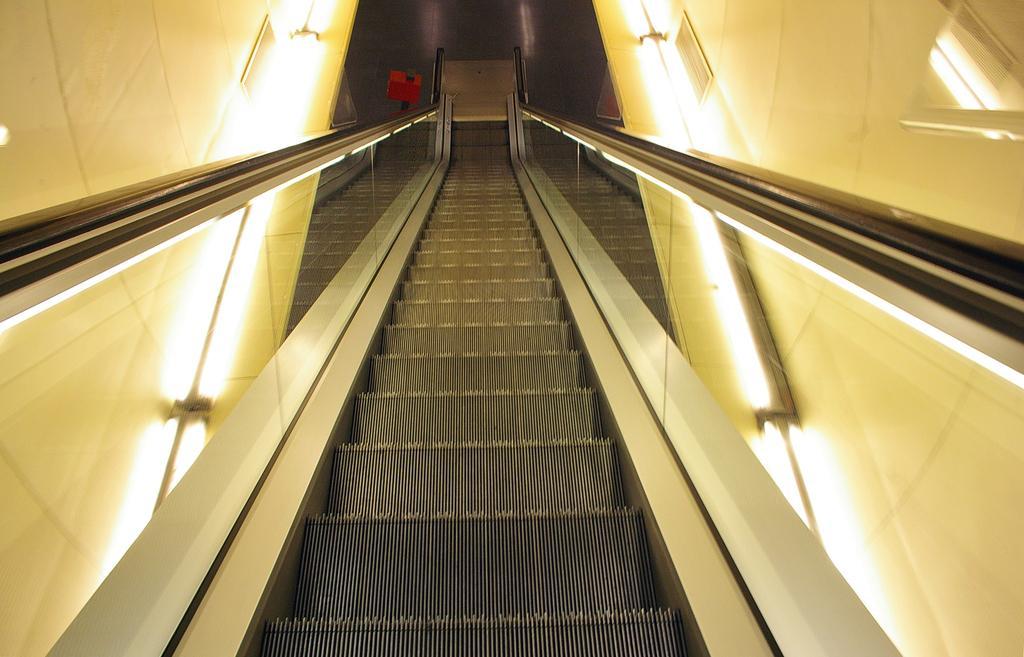Can you describe this image briefly? In this image I can see stairs in the centre and both side of it I can see number of lights. On the top of this image I can see a red color thing. 